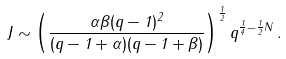<formula> <loc_0><loc_0><loc_500><loc_500>J \sim \left ( \frac { \alpha \beta ( q - 1 ) ^ { 2 } } { ( q - 1 + \alpha ) ( q - 1 + \beta ) } \right ) ^ { \frac { 1 } { 2 } } q ^ { \frac { 1 } { 4 } - \frac { 1 } { 2 } N } \, .</formula> 